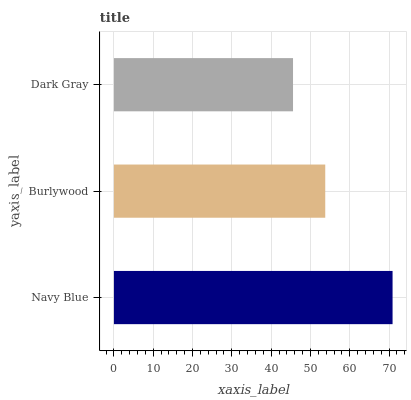Is Dark Gray the minimum?
Answer yes or no. Yes. Is Navy Blue the maximum?
Answer yes or no. Yes. Is Burlywood the minimum?
Answer yes or no. No. Is Burlywood the maximum?
Answer yes or no. No. Is Navy Blue greater than Burlywood?
Answer yes or no. Yes. Is Burlywood less than Navy Blue?
Answer yes or no. Yes. Is Burlywood greater than Navy Blue?
Answer yes or no. No. Is Navy Blue less than Burlywood?
Answer yes or no. No. Is Burlywood the high median?
Answer yes or no. Yes. Is Burlywood the low median?
Answer yes or no. Yes. Is Navy Blue the high median?
Answer yes or no. No. Is Navy Blue the low median?
Answer yes or no. No. 